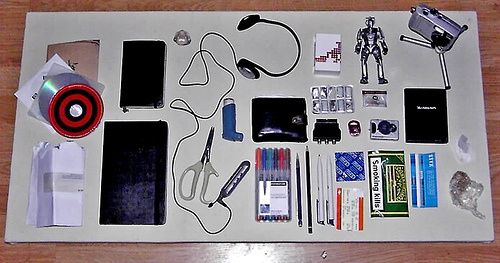Describe the objects in this image and their specific colors. I can see scissors in brown, darkgray, lightgray, gray, and black tones in this image. 